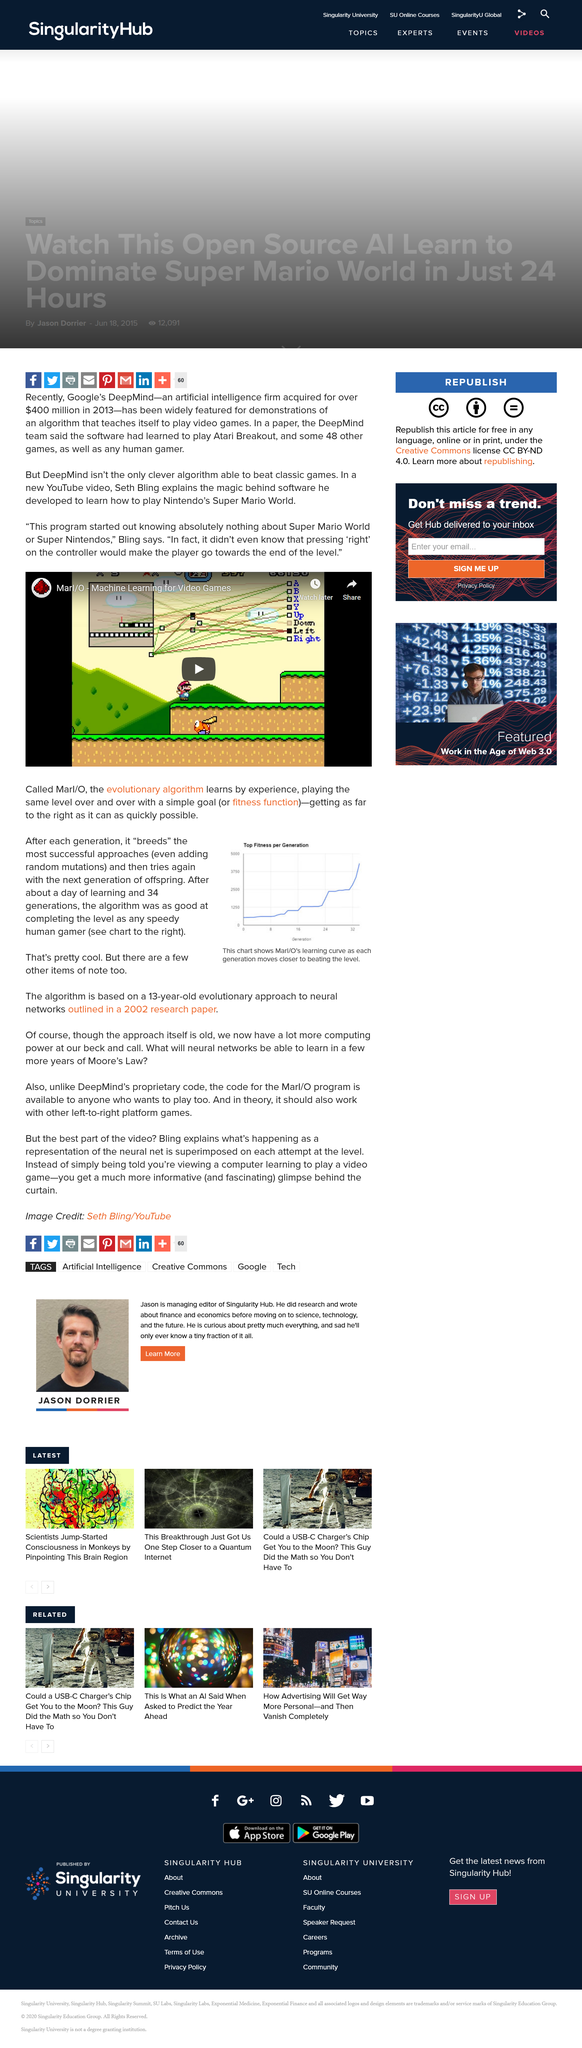Highlight a few significant elements in this photo. Yes, it does. Did Marl/O know anything about Super Mario World starting out? No, it did not. The evolutionary algorithm, a type of optimization technique inspired by the process of natural selection, is known as Marl/O. 